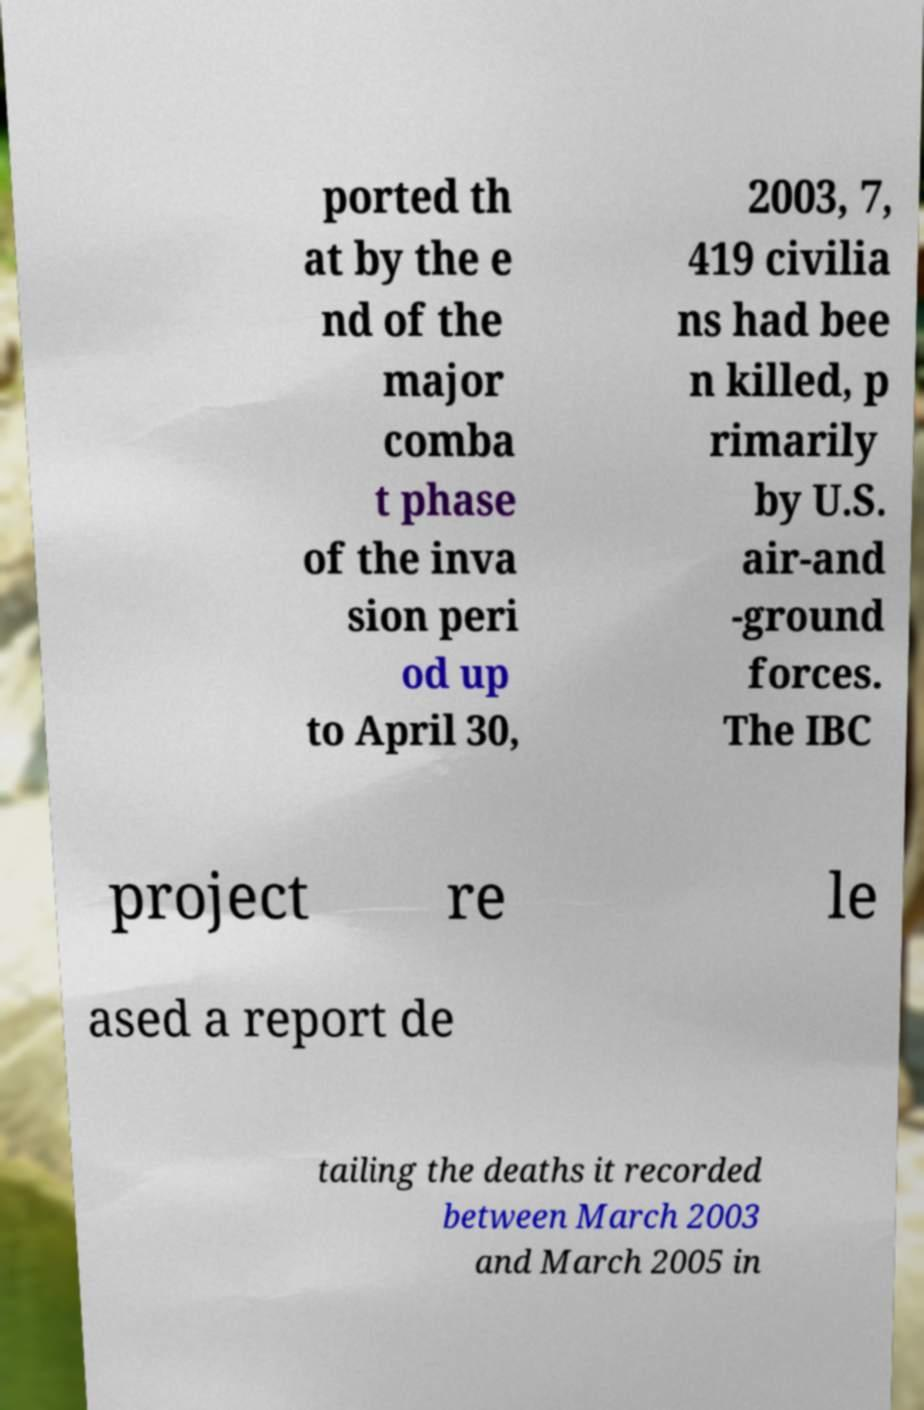I need the written content from this picture converted into text. Can you do that? ported th at by the e nd of the major comba t phase of the inva sion peri od up to April 30, 2003, 7, 419 civilia ns had bee n killed, p rimarily by U.S. air-and -ground forces. The IBC project re le ased a report de tailing the deaths it recorded between March 2003 and March 2005 in 